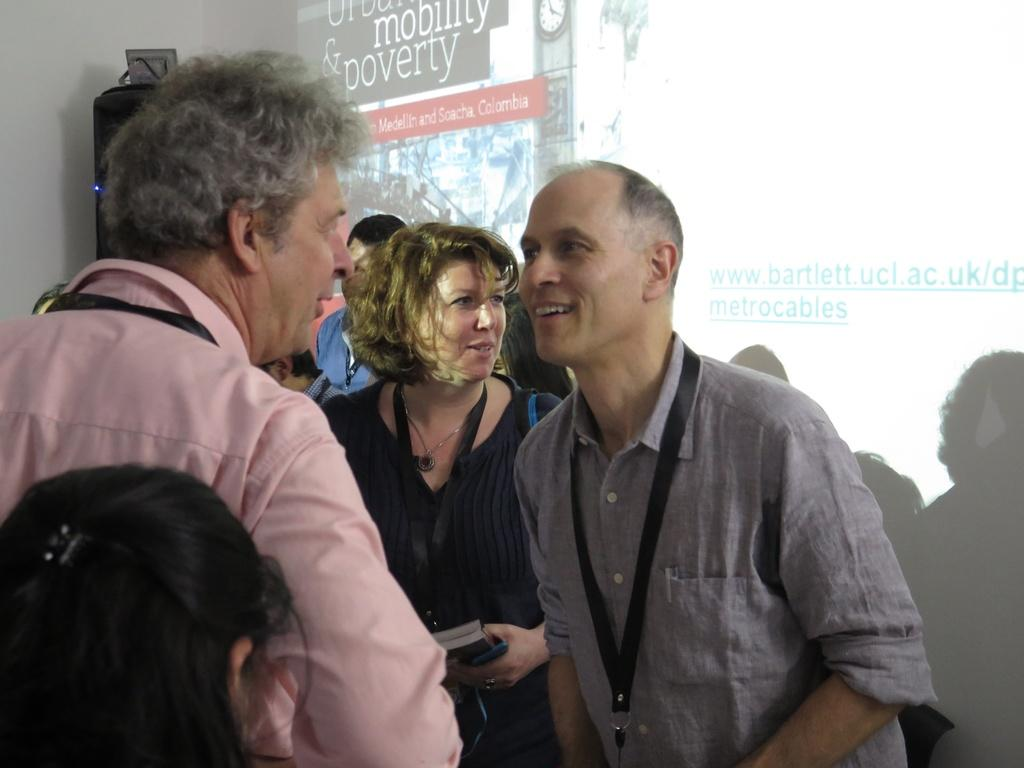How many people are in the image? There is a group of people standing in the image. What can be seen in the background of the image? There is a screen and an object in the background of the image. What type of crate is being used by the people in the image? There is no crate present in the image. What are the people teaching in the image? There is no indication in the image that the people are teaching in the image. 